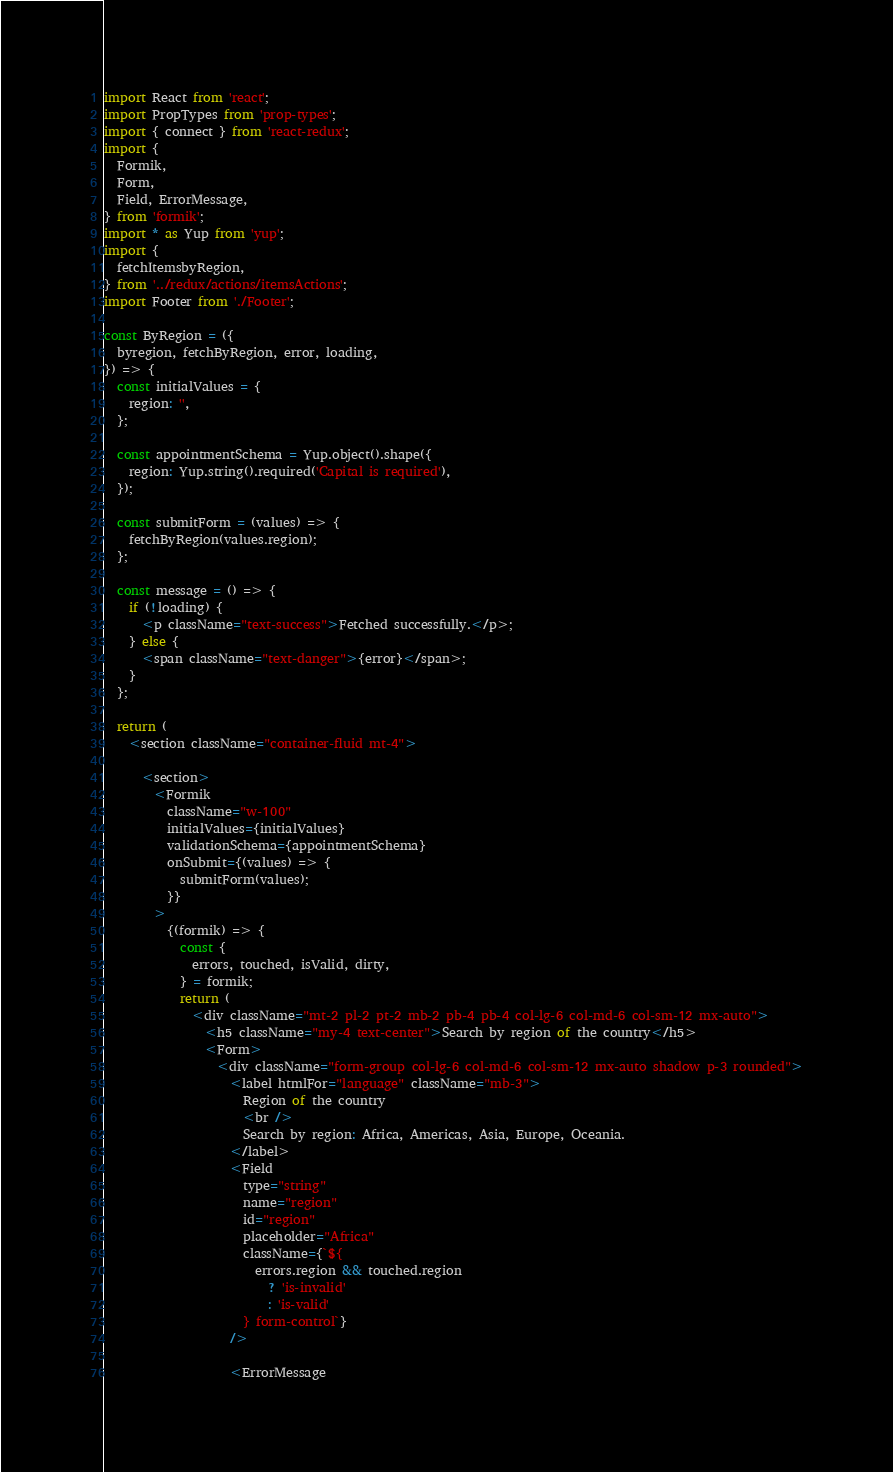<code> <loc_0><loc_0><loc_500><loc_500><_JavaScript_>import React from 'react';
import PropTypes from 'prop-types';
import { connect } from 'react-redux';
import {
  Formik,
  Form,
  Field, ErrorMessage,
} from 'formik';
import * as Yup from 'yup';
import {
  fetchItemsbyRegion,
} from '../redux/actions/itemsActions';
import Footer from './Footer';

const ByRegion = ({
  byregion, fetchByRegion, error, loading,
}) => {
  const initialValues = {
    region: '',
  };

  const appointmentSchema = Yup.object().shape({
    region: Yup.string().required('Capital is required'),
  });

  const submitForm = (values) => {
    fetchByRegion(values.region);
  };

  const message = () => {
    if (!loading) {
      <p className="text-success">Fetched successfully.</p>;
    } else {
      <span className="text-danger">{error}</span>;
    }
  };

  return (
    <section className="container-fluid mt-4">

      <section>
        <Formik
          className="w-100"
          initialValues={initialValues}
          validationSchema={appointmentSchema}
          onSubmit={(values) => {
            submitForm(values);
          }}
        >
          {(formik) => {
            const {
              errors, touched, isValid, dirty,
            } = formik;
            return (
              <div className="mt-2 pl-2 pt-2 mb-2 pb-4 pb-4 col-lg-6 col-md-6 col-sm-12 mx-auto">
                <h5 className="my-4 text-center">Search by region of the country</h5>
                <Form>
                  <div className="form-group col-lg-6 col-md-6 col-sm-12 mx-auto shadow p-3 rounded">
                    <label htmlFor="language" className="mb-3">
                      Region of the country
                      <br />
                      Search by region: Africa, Americas, Asia, Europe, Oceania.
                    </label>
                    <Field
                      type="string"
                      name="region"
                      id="region"
                      placeholder="Africa"
                      className={`${
                        errors.region && touched.region
                          ? 'is-invalid'
                          : 'is-valid'
                      } form-control`}
                    />

                    <ErrorMessage</code> 